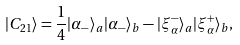Convert formula to latex. <formula><loc_0><loc_0><loc_500><loc_500>| { C _ { 2 1 } } \rangle = \frac { 1 } { 4 } | \alpha _ { - } \rangle _ { a } | \alpha _ { - } \rangle _ { b } - | \xi _ { \alpha } ^ { - } \rangle _ { a } | \xi _ { \alpha } ^ { + } \rangle _ { b } ,</formula> 